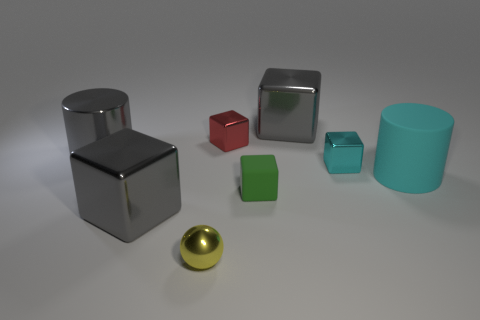Add 1 tiny gray matte cylinders. How many objects exist? 9 Subtract all brown balls. How many gray cubes are left? 2 Subtract 2 blocks. How many blocks are left? 3 Subtract all red blocks. How many blocks are left? 4 Subtract all tiny green rubber blocks. How many blocks are left? 4 Subtract all purple cubes. Subtract all yellow spheres. How many cubes are left? 5 Subtract all spheres. How many objects are left? 7 Add 1 green cubes. How many green cubes are left? 2 Add 4 green matte cubes. How many green matte cubes exist? 5 Subtract 0 cyan balls. How many objects are left? 8 